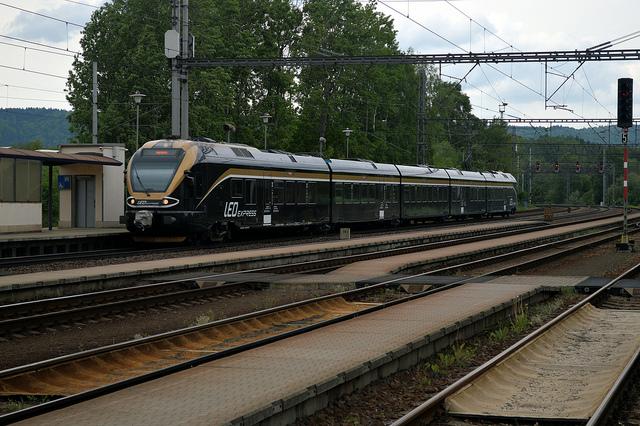Is it cloudy?
Write a very short answer. Yes. Is the train stopping?
Concise answer only. Yes. How many red trains are there?
Concise answer only. 0. What color is the train?
Keep it brief. Black. Does this train carry people or cargo?
Answer briefly. People. What is on the rails?
Be succinct. Train. What color is the stripe on the train?
Answer briefly. Yellow. 